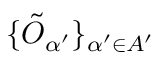<formula> <loc_0><loc_0><loc_500><loc_500>\{ \tilde { O } _ { \alpha ^ { \prime } } \} _ { \alpha ^ { \prime } \in A ^ { \prime } }</formula> 